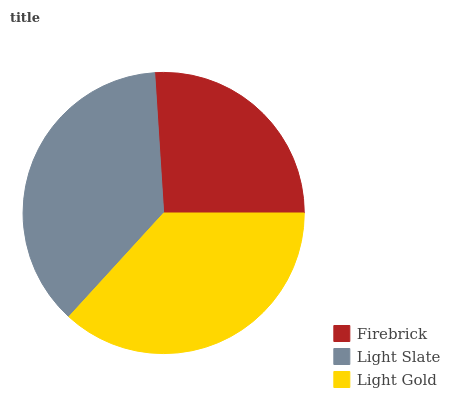Is Firebrick the minimum?
Answer yes or no. Yes. Is Light Slate the maximum?
Answer yes or no. Yes. Is Light Gold the minimum?
Answer yes or no. No. Is Light Gold the maximum?
Answer yes or no. No. Is Light Slate greater than Light Gold?
Answer yes or no. Yes. Is Light Gold less than Light Slate?
Answer yes or no. Yes. Is Light Gold greater than Light Slate?
Answer yes or no. No. Is Light Slate less than Light Gold?
Answer yes or no. No. Is Light Gold the high median?
Answer yes or no. Yes. Is Light Gold the low median?
Answer yes or no. Yes. Is Firebrick the high median?
Answer yes or no. No. Is Light Slate the low median?
Answer yes or no. No. 